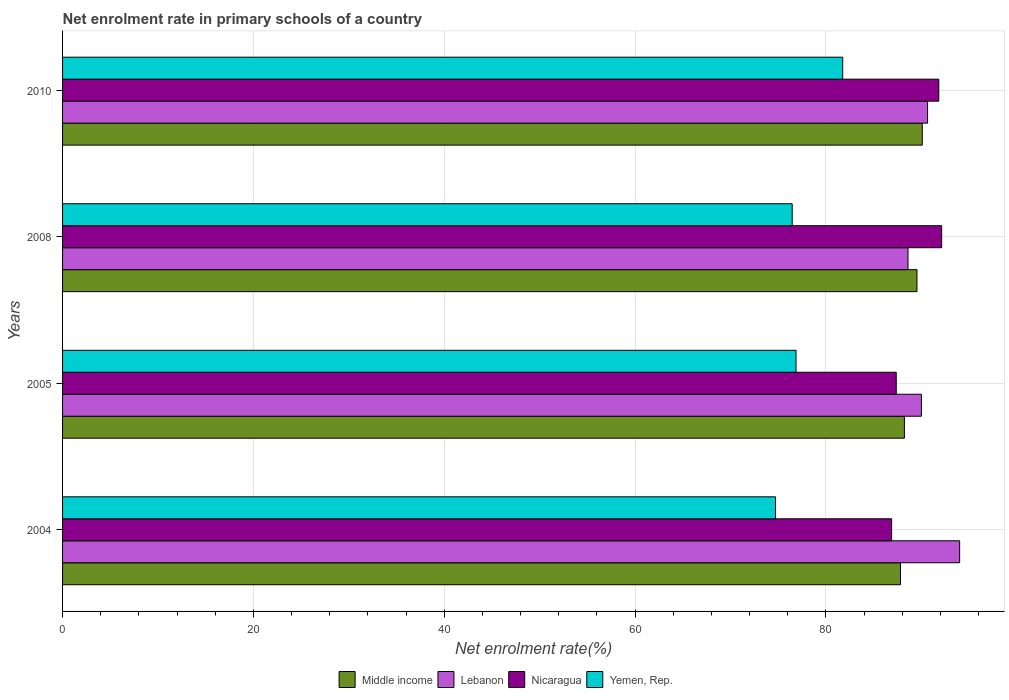How many different coloured bars are there?
Your answer should be very brief. 4. How many groups of bars are there?
Your answer should be compact. 4. Are the number of bars on each tick of the Y-axis equal?
Keep it short and to the point. Yes. What is the net enrolment rate in primary schools in Lebanon in 2005?
Provide a short and direct response. 90. Across all years, what is the maximum net enrolment rate in primary schools in Nicaragua?
Give a very brief answer. 92.12. Across all years, what is the minimum net enrolment rate in primary schools in Nicaragua?
Keep it short and to the point. 86.88. In which year was the net enrolment rate in primary schools in Lebanon maximum?
Offer a terse response. 2004. What is the total net enrolment rate in primary schools in Lebanon in the graph?
Keep it short and to the point. 363.26. What is the difference between the net enrolment rate in primary schools in Lebanon in 2004 and that in 2005?
Keep it short and to the point. 4.01. What is the difference between the net enrolment rate in primary schools in Lebanon in 2005 and the net enrolment rate in primary schools in Nicaragua in 2008?
Your answer should be compact. -2.12. What is the average net enrolment rate in primary schools in Middle income per year?
Make the answer very short. 88.91. In the year 2008, what is the difference between the net enrolment rate in primary schools in Middle income and net enrolment rate in primary schools in Yemen, Rep.?
Ensure brevity in your answer.  13.08. What is the ratio of the net enrolment rate in primary schools in Yemen, Rep. in 2004 to that in 2005?
Offer a very short reply. 0.97. Is the net enrolment rate in primary schools in Middle income in 2005 less than that in 2010?
Offer a very short reply. Yes. Is the difference between the net enrolment rate in primary schools in Middle income in 2005 and 2010 greater than the difference between the net enrolment rate in primary schools in Yemen, Rep. in 2005 and 2010?
Keep it short and to the point. Yes. What is the difference between the highest and the second highest net enrolment rate in primary schools in Middle income?
Give a very brief answer. 0.55. What is the difference between the highest and the lowest net enrolment rate in primary schools in Middle income?
Offer a very short reply. 2.29. In how many years, is the net enrolment rate in primary schools in Middle income greater than the average net enrolment rate in primary schools in Middle income taken over all years?
Keep it short and to the point. 2. Is it the case that in every year, the sum of the net enrolment rate in primary schools in Middle income and net enrolment rate in primary schools in Lebanon is greater than the sum of net enrolment rate in primary schools in Yemen, Rep. and net enrolment rate in primary schools in Nicaragua?
Ensure brevity in your answer.  Yes. What does the 1st bar from the top in 2008 represents?
Ensure brevity in your answer.  Yemen, Rep. What does the 1st bar from the bottom in 2010 represents?
Your answer should be compact. Middle income. Is it the case that in every year, the sum of the net enrolment rate in primary schools in Lebanon and net enrolment rate in primary schools in Nicaragua is greater than the net enrolment rate in primary schools in Middle income?
Ensure brevity in your answer.  Yes. How many bars are there?
Keep it short and to the point. 16. What is the difference between two consecutive major ticks on the X-axis?
Keep it short and to the point. 20. Are the values on the major ticks of X-axis written in scientific E-notation?
Ensure brevity in your answer.  No. How many legend labels are there?
Offer a terse response. 4. How are the legend labels stacked?
Your response must be concise. Horizontal. What is the title of the graph?
Offer a terse response. Net enrolment rate in primary schools of a country. Does "Sweden" appear as one of the legend labels in the graph?
Provide a succinct answer. No. What is the label or title of the X-axis?
Your response must be concise. Net enrolment rate(%). What is the label or title of the Y-axis?
Make the answer very short. Years. What is the Net enrolment rate(%) in Middle income in 2004?
Provide a succinct answer. 87.81. What is the Net enrolment rate(%) in Lebanon in 2004?
Make the answer very short. 94.01. What is the Net enrolment rate(%) of Nicaragua in 2004?
Offer a very short reply. 86.88. What is the Net enrolment rate(%) of Yemen, Rep. in 2004?
Provide a succinct answer. 74.71. What is the Net enrolment rate(%) in Middle income in 2005?
Ensure brevity in your answer.  88.22. What is the Net enrolment rate(%) in Lebanon in 2005?
Ensure brevity in your answer.  90. What is the Net enrolment rate(%) of Nicaragua in 2005?
Offer a very short reply. 87.37. What is the Net enrolment rate(%) of Yemen, Rep. in 2005?
Your answer should be compact. 76.86. What is the Net enrolment rate(%) of Middle income in 2008?
Offer a very short reply. 89.54. What is the Net enrolment rate(%) in Lebanon in 2008?
Provide a succinct answer. 88.6. What is the Net enrolment rate(%) of Nicaragua in 2008?
Provide a short and direct response. 92.12. What is the Net enrolment rate(%) in Yemen, Rep. in 2008?
Offer a very short reply. 76.46. What is the Net enrolment rate(%) in Middle income in 2010?
Give a very brief answer. 90.09. What is the Net enrolment rate(%) in Lebanon in 2010?
Provide a succinct answer. 90.65. What is the Net enrolment rate(%) in Nicaragua in 2010?
Your answer should be very brief. 91.82. What is the Net enrolment rate(%) in Yemen, Rep. in 2010?
Make the answer very short. 81.75. Across all years, what is the maximum Net enrolment rate(%) in Middle income?
Offer a very short reply. 90.09. Across all years, what is the maximum Net enrolment rate(%) of Lebanon?
Make the answer very short. 94.01. Across all years, what is the maximum Net enrolment rate(%) of Nicaragua?
Provide a succinct answer. 92.12. Across all years, what is the maximum Net enrolment rate(%) of Yemen, Rep.?
Offer a terse response. 81.75. Across all years, what is the minimum Net enrolment rate(%) in Middle income?
Offer a terse response. 87.81. Across all years, what is the minimum Net enrolment rate(%) in Lebanon?
Your answer should be compact. 88.6. Across all years, what is the minimum Net enrolment rate(%) of Nicaragua?
Provide a short and direct response. 86.88. Across all years, what is the minimum Net enrolment rate(%) of Yemen, Rep.?
Offer a very short reply. 74.71. What is the total Net enrolment rate(%) of Middle income in the graph?
Your answer should be compact. 355.66. What is the total Net enrolment rate(%) of Lebanon in the graph?
Give a very brief answer. 363.26. What is the total Net enrolment rate(%) of Nicaragua in the graph?
Your answer should be very brief. 358.19. What is the total Net enrolment rate(%) in Yemen, Rep. in the graph?
Your answer should be compact. 309.79. What is the difference between the Net enrolment rate(%) of Middle income in 2004 and that in 2005?
Give a very brief answer. -0.41. What is the difference between the Net enrolment rate(%) in Lebanon in 2004 and that in 2005?
Offer a terse response. 4.01. What is the difference between the Net enrolment rate(%) in Nicaragua in 2004 and that in 2005?
Offer a very short reply. -0.48. What is the difference between the Net enrolment rate(%) of Yemen, Rep. in 2004 and that in 2005?
Offer a very short reply. -2.15. What is the difference between the Net enrolment rate(%) of Middle income in 2004 and that in 2008?
Make the answer very short. -1.73. What is the difference between the Net enrolment rate(%) in Lebanon in 2004 and that in 2008?
Your answer should be compact. 5.41. What is the difference between the Net enrolment rate(%) of Nicaragua in 2004 and that in 2008?
Your answer should be very brief. -5.24. What is the difference between the Net enrolment rate(%) in Yemen, Rep. in 2004 and that in 2008?
Offer a terse response. -1.75. What is the difference between the Net enrolment rate(%) of Middle income in 2004 and that in 2010?
Ensure brevity in your answer.  -2.29. What is the difference between the Net enrolment rate(%) of Lebanon in 2004 and that in 2010?
Your response must be concise. 3.36. What is the difference between the Net enrolment rate(%) in Nicaragua in 2004 and that in 2010?
Your response must be concise. -4.94. What is the difference between the Net enrolment rate(%) of Yemen, Rep. in 2004 and that in 2010?
Make the answer very short. -7.04. What is the difference between the Net enrolment rate(%) in Middle income in 2005 and that in 2008?
Your answer should be compact. -1.32. What is the difference between the Net enrolment rate(%) of Lebanon in 2005 and that in 2008?
Make the answer very short. 1.41. What is the difference between the Net enrolment rate(%) in Nicaragua in 2005 and that in 2008?
Provide a short and direct response. -4.76. What is the difference between the Net enrolment rate(%) in Yemen, Rep. in 2005 and that in 2008?
Offer a terse response. 0.4. What is the difference between the Net enrolment rate(%) of Middle income in 2005 and that in 2010?
Keep it short and to the point. -1.87. What is the difference between the Net enrolment rate(%) of Lebanon in 2005 and that in 2010?
Your response must be concise. -0.64. What is the difference between the Net enrolment rate(%) in Nicaragua in 2005 and that in 2010?
Offer a very short reply. -4.46. What is the difference between the Net enrolment rate(%) in Yemen, Rep. in 2005 and that in 2010?
Your answer should be compact. -4.89. What is the difference between the Net enrolment rate(%) in Middle income in 2008 and that in 2010?
Your answer should be compact. -0.55. What is the difference between the Net enrolment rate(%) in Lebanon in 2008 and that in 2010?
Your answer should be compact. -2.05. What is the difference between the Net enrolment rate(%) in Nicaragua in 2008 and that in 2010?
Offer a terse response. 0.3. What is the difference between the Net enrolment rate(%) in Yemen, Rep. in 2008 and that in 2010?
Keep it short and to the point. -5.29. What is the difference between the Net enrolment rate(%) of Middle income in 2004 and the Net enrolment rate(%) of Lebanon in 2005?
Your response must be concise. -2.2. What is the difference between the Net enrolment rate(%) in Middle income in 2004 and the Net enrolment rate(%) in Nicaragua in 2005?
Give a very brief answer. 0.44. What is the difference between the Net enrolment rate(%) of Middle income in 2004 and the Net enrolment rate(%) of Yemen, Rep. in 2005?
Ensure brevity in your answer.  10.94. What is the difference between the Net enrolment rate(%) of Lebanon in 2004 and the Net enrolment rate(%) of Nicaragua in 2005?
Provide a succinct answer. 6.64. What is the difference between the Net enrolment rate(%) in Lebanon in 2004 and the Net enrolment rate(%) in Yemen, Rep. in 2005?
Your answer should be compact. 17.14. What is the difference between the Net enrolment rate(%) of Nicaragua in 2004 and the Net enrolment rate(%) of Yemen, Rep. in 2005?
Ensure brevity in your answer.  10.02. What is the difference between the Net enrolment rate(%) in Middle income in 2004 and the Net enrolment rate(%) in Lebanon in 2008?
Offer a terse response. -0.79. What is the difference between the Net enrolment rate(%) of Middle income in 2004 and the Net enrolment rate(%) of Nicaragua in 2008?
Make the answer very short. -4.32. What is the difference between the Net enrolment rate(%) of Middle income in 2004 and the Net enrolment rate(%) of Yemen, Rep. in 2008?
Your response must be concise. 11.35. What is the difference between the Net enrolment rate(%) in Lebanon in 2004 and the Net enrolment rate(%) in Nicaragua in 2008?
Your answer should be very brief. 1.88. What is the difference between the Net enrolment rate(%) in Lebanon in 2004 and the Net enrolment rate(%) in Yemen, Rep. in 2008?
Provide a short and direct response. 17.55. What is the difference between the Net enrolment rate(%) of Nicaragua in 2004 and the Net enrolment rate(%) of Yemen, Rep. in 2008?
Provide a short and direct response. 10.42. What is the difference between the Net enrolment rate(%) in Middle income in 2004 and the Net enrolment rate(%) in Lebanon in 2010?
Give a very brief answer. -2.84. What is the difference between the Net enrolment rate(%) of Middle income in 2004 and the Net enrolment rate(%) of Nicaragua in 2010?
Offer a very short reply. -4.01. What is the difference between the Net enrolment rate(%) of Middle income in 2004 and the Net enrolment rate(%) of Yemen, Rep. in 2010?
Make the answer very short. 6.05. What is the difference between the Net enrolment rate(%) in Lebanon in 2004 and the Net enrolment rate(%) in Nicaragua in 2010?
Your answer should be very brief. 2.19. What is the difference between the Net enrolment rate(%) in Lebanon in 2004 and the Net enrolment rate(%) in Yemen, Rep. in 2010?
Ensure brevity in your answer.  12.25. What is the difference between the Net enrolment rate(%) in Nicaragua in 2004 and the Net enrolment rate(%) in Yemen, Rep. in 2010?
Your answer should be very brief. 5.13. What is the difference between the Net enrolment rate(%) in Middle income in 2005 and the Net enrolment rate(%) in Lebanon in 2008?
Your response must be concise. -0.38. What is the difference between the Net enrolment rate(%) in Middle income in 2005 and the Net enrolment rate(%) in Nicaragua in 2008?
Offer a very short reply. -3.9. What is the difference between the Net enrolment rate(%) in Middle income in 2005 and the Net enrolment rate(%) in Yemen, Rep. in 2008?
Make the answer very short. 11.76. What is the difference between the Net enrolment rate(%) of Lebanon in 2005 and the Net enrolment rate(%) of Nicaragua in 2008?
Offer a terse response. -2.12. What is the difference between the Net enrolment rate(%) of Lebanon in 2005 and the Net enrolment rate(%) of Yemen, Rep. in 2008?
Keep it short and to the point. 13.54. What is the difference between the Net enrolment rate(%) of Nicaragua in 2005 and the Net enrolment rate(%) of Yemen, Rep. in 2008?
Your answer should be compact. 10.91. What is the difference between the Net enrolment rate(%) of Middle income in 2005 and the Net enrolment rate(%) of Lebanon in 2010?
Your answer should be very brief. -2.43. What is the difference between the Net enrolment rate(%) of Middle income in 2005 and the Net enrolment rate(%) of Nicaragua in 2010?
Your response must be concise. -3.6. What is the difference between the Net enrolment rate(%) of Middle income in 2005 and the Net enrolment rate(%) of Yemen, Rep. in 2010?
Offer a terse response. 6.47. What is the difference between the Net enrolment rate(%) of Lebanon in 2005 and the Net enrolment rate(%) of Nicaragua in 2010?
Make the answer very short. -1.82. What is the difference between the Net enrolment rate(%) of Lebanon in 2005 and the Net enrolment rate(%) of Yemen, Rep. in 2010?
Give a very brief answer. 8.25. What is the difference between the Net enrolment rate(%) of Nicaragua in 2005 and the Net enrolment rate(%) of Yemen, Rep. in 2010?
Your response must be concise. 5.61. What is the difference between the Net enrolment rate(%) in Middle income in 2008 and the Net enrolment rate(%) in Lebanon in 2010?
Give a very brief answer. -1.11. What is the difference between the Net enrolment rate(%) of Middle income in 2008 and the Net enrolment rate(%) of Nicaragua in 2010?
Offer a terse response. -2.28. What is the difference between the Net enrolment rate(%) of Middle income in 2008 and the Net enrolment rate(%) of Yemen, Rep. in 2010?
Make the answer very short. 7.78. What is the difference between the Net enrolment rate(%) in Lebanon in 2008 and the Net enrolment rate(%) in Nicaragua in 2010?
Your response must be concise. -3.22. What is the difference between the Net enrolment rate(%) in Lebanon in 2008 and the Net enrolment rate(%) in Yemen, Rep. in 2010?
Provide a succinct answer. 6.84. What is the difference between the Net enrolment rate(%) in Nicaragua in 2008 and the Net enrolment rate(%) in Yemen, Rep. in 2010?
Make the answer very short. 10.37. What is the average Net enrolment rate(%) in Middle income per year?
Your response must be concise. 88.91. What is the average Net enrolment rate(%) in Lebanon per year?
Offer a very short reply. 90.81. What is the average Net enrolment rate(%) in Nicaragua per year?
Your answer should be compact. 89.55. What is the average Net enrolment rate(%) of Yemen, Rep. per year?
Offer a very short reply. 77.45. In the year 2004, what is the difference between the Net enrolment rate(%) in Middle income and Net enrolment rate(%) in Lebanon?
Your answer should be compact. -6.2. In the year 2004, what is the difference between the Net enrolment rate(%) in Middle income and Net enrolment rate(%) in Nicaragua?
Your answer should be very brief. 0.93. In the year 2004, what is the difference between the Net enrolment rate(%) of Middle income and Net enrolment rate(%) of Yemen, Rep.?
Offer a terse response. 13.09. In the year 2004, what is the difference between the Net enrolment rate(%) of Lebanon and Net enrolment rate(%) of Nicaragua?
Offer a very short reply. 7.13. In the year 2004, what is the difference between the Net enrolment rate(%) in Lebanon and Net enrolment rate(%) in Yemen, Rep.?
Offer a terse response. 19.29. In the year 2004, what is the difference between the Net enrolment rate(%) of Nicaragua and Net enrolment rate(%) of Yemen, Rep.?
Provide a succinct answer. 12.17. In the year 2005, what is the difference between the Net enrolment rate(%) in Middle income and Net enrolment rate(%) in Lebanon?
Your answer should be compact. -1.78. In the year 2005, what is the difference between the Net enrolment rate(%) of Middle income and Net enrolment rate(%) of Nicaragua?
Your answer should be very brief. 0.85. In the year 2005, what is the difference between the Net enrolment rate(%) in Middle income and Net enrolment rate(%) in Yemen, Rep.?
Offer a very short reply. 11.36. In the year 2005, what is the difference between the Net enrolment rate(%) in Lebanon and Net enrolment rate(%) in Nicaragua?
Keep it short and to the point. 2.64. In the year 2005, what is the difference between the Net enrolment rate(%) of Lebanon and Net enrolment rate(%) of Yemen, Rep.?
Keep it short and to the point. 13.14. In the year 2005, what is the difference between the Net enrolment rate(%) of Nicaragua and Net enrolment rate(%) of Yemen, Rep.?
Your response must be concise. 10.5. In the year 2008, what is the difference between the Net enrolment rate(%) in Middle income and Net enrolment rate(%) in Lebanon?
Provide a succinct answer. 0.94. In the year 2008, what is the difference between the Net enrolment rate(%) in Middle income and Net enrolment rate(%) in Nicaragua?
Your response must be concise. -2.59. In the year 2008, what is the difference between the Net enrolment rate(%) in Middle income and Net enrolment rate(%) in Yemen, Rep.?
Your response must be concise. 13.08. In the year 2008, what is the difference between the Net enrolment rate(%) in Lebanon and Net enrolment rate(%) in Nicaragua?
Offer a very short reply. -3.53. In the year 2008, what is the difference between the Net enrolment rate(%) in Lebanon and Net enrolment rate(%) in Yemen, Rep.?
Your answer should be very brief. 12.14. In the year 2008, what is the difference between the Net enrolment rate(%) in Nicaragua and Net enrolment rate(%) in Yemen, Rep.?
Your response must be concise. 15.66. In the year 2010, what is the difference between the Net enrolment rate(%) of Middle income and Net enrolment rate(%) of Lebanon?
Offer a very short reply. -0.56. In the year 2010, what is the difference between the Net enrolment rate(%) of Middle income and Net enrolment rate(%) of Nicaragua?
Your response must be concise. -1.73. In the year 2010, what is the difference between the Net enrolment rate(%) in Middle income and Net enrolment rate(%) in Yemen, Rep.?
Give a very brief answer. 8.34. In the year 2010, what is the difference between the Net enrolment rate(%) of Lebanon and Net enrolment rate(%) of Nicaragua?
Your answer should be compact. -1.17. In the year 2010, what is the difference between the Net enrolment rate(%) of Lebanon and Net enrolment rate(%) of Yemen, Rep.?
Your answer should be compact. 8.89. In the year 2010, what is the difference between the Net enrolment rate(%) of Nicaragua and Net enrolment rate(%) of Yemen, Rep.?
Give a very brief answer. 10.07. What is the ratio of the Net enrolment rate(%) in Lebanon in 2004 to that in 2005?
Provide a succinct answer. 1.04. What is the ratio of the Net enrolment rate(%) of Yemen, Rep. in 2004 to that in 2005?
Ensure brevity in your answer.  0.97. What is the ratio of the Net enrolment rate(%) of Middle income in 2004 to that in 2008?
Your answer should be compact. 0.98. What is the ratio of the Net enrolment rate(%) in Lebanon in 2004 to that in 2008?
Give a very brief answer. 1.06. What is the ratio of the Net enrolment rate(%) of Nicaragua in 2004 to that in 2008?
Your response must be concise. 0.94. What is the ratio of the Net enrolment rate(%) of Yemen, Rep. in 2004 to that in 2008?
Provide a short and direct response. 0.98. What is the ratio of the Net enrolment rate(%) in Middle income in 2004 to that in 2010?
Provide a succinct answer. 0.97. What is the ratio of the Net enrolment rate(%) in Lebanon in 2004 to that in 2010?
Provide a succinct answer. 1.04. What is the ratio of the Net enrolment rate(%) in Nicaragua in 2004 to that in 2010?
Your response must be concise. 0.95. What is the ratio of the Net enrolment rate(%) of Yemen, Rep. in 2004 to that in 2010?
Your answer should be compact. 0.91. What is the ratio of the Net enrolment rate(%) in Lebanon in 2005 to that in 2008?
Make the answer very short. 1.02. What is the ratio of the Net enrolment rate(%) of Nicaragua in 2005 to that in 2008?
Make the answer very short. 0.95. What is the ratio of the Net enrolment rate(%) of Yemen, Rep. in 2005 to that in 2008?
Offer a terse response. 1.01. What is the ratio of the Net enrolment rate(%) in Middle income in 2005 to that in 2010?
Offer a very short reply. 0.98. What is the ratio of the Net enrolment rate(%) in Nicaragua in 2005 to that in 2010?
Give a very brief answer. 0.95. What is the ratio of the Net enrolment rate(%) of Yemen, Rep. in 2005 to that in 2010?
Keep it short and to the point. 0.94. What is the ratio of the Net enrolment rate(%) in Middle income in 2008 to that in 2010?
Give a very brief answer. 0.99. What is the ratio of the Net enrolment rate(%) in Lebanon in 2008 to that in 2010?
Your response must be concise. 0.98. What is the ratio of the Net enrolment rate(%) of Nicaragua in 2008 to that in 2010?
Offer a terse response. 1. What is the ratio of the Net enrolment rate(%) of Yemen, Rep. in 2008 to that in 2010?
Offer a terse response. 0.94. What is the difference between the highest and the second highest Net enrolment rate(%) of Middle income?
Give a very brief answer. 0.55. What is the difference between the highest and the second highest Net enrolment rate(%) in Lebanon?
Give a very brief answer. 3.36. What is the difference between the highest and the second highest Net enrolment rate(%) in Nicaragua?
Your response must be concise. 0.3. What is the difference between the highest and the second highest Net enrolment rate(%) of Yemen, Rep.?
Provide a succinct answer. 4.89. What is the difference between the highest and the lowest Net enrolment rate(%) in Middle income?
Offer a very short reply. 2.29. What is the difference between the highest and the lowest Net enrolment rate(%) in Lebanon?
Ensure brevity in your answer.  5.41. What is the difference between the highest and the lowest Net enrolment rate(%) of Nicaragua?
Give a very brief answer. 5.24. What is the difference between the highest and the lowest Net enrolment rate(%) in Yemen, Rep.?
Give a very brief answer. 7.04. 